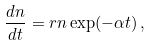<formula> <loc_0><loc_0><loc_500><loc_500>\frac { d n } { d t } = r n \exp ( - \alpha t ) \, ,</formula> 